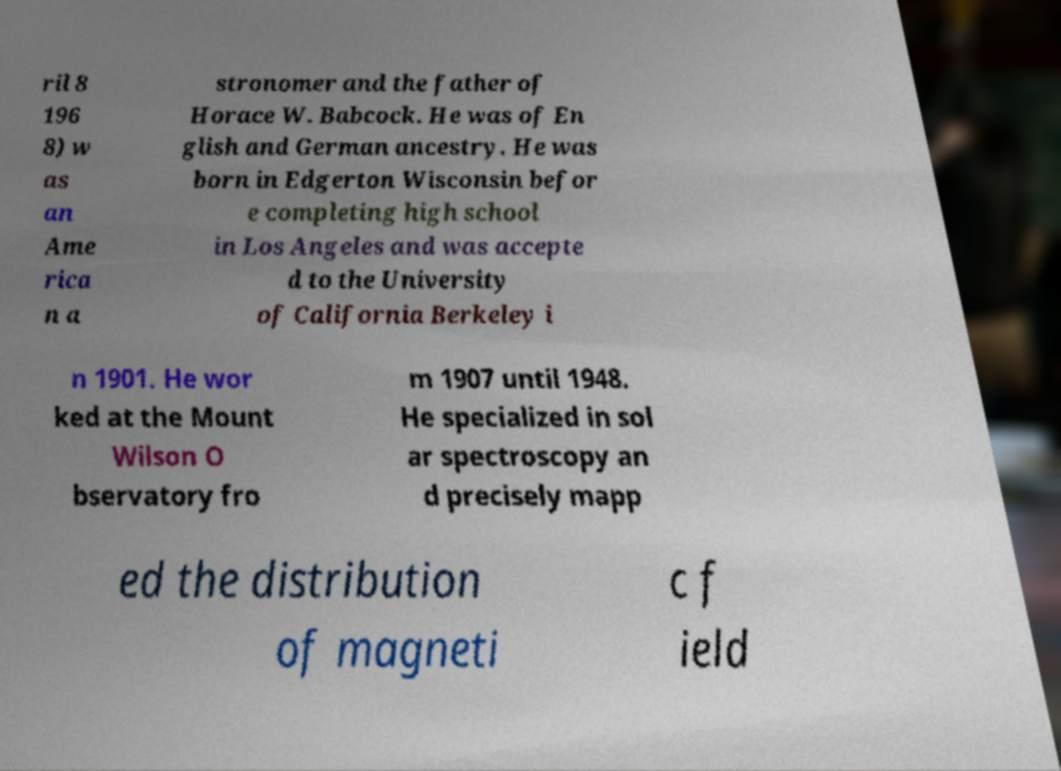Could you assist in decoding the text presented in this image and type it out clearly? ril 8 196 8) w as an Ame rica n a stronomer and the father of Horace W. Babcock. He was of En glish and German ancestry. He was born in Edgerton Wisconsin befor e completing high school in Los Angeles and was accepte d to the University of California Berkeley i n 1901. He wor ked at the Mount Wilson O bservatory fro m 1907 until 1948. He specialized in sol ar spectroscopy an d precisely mapp ed the distribution of magneti c f ield 